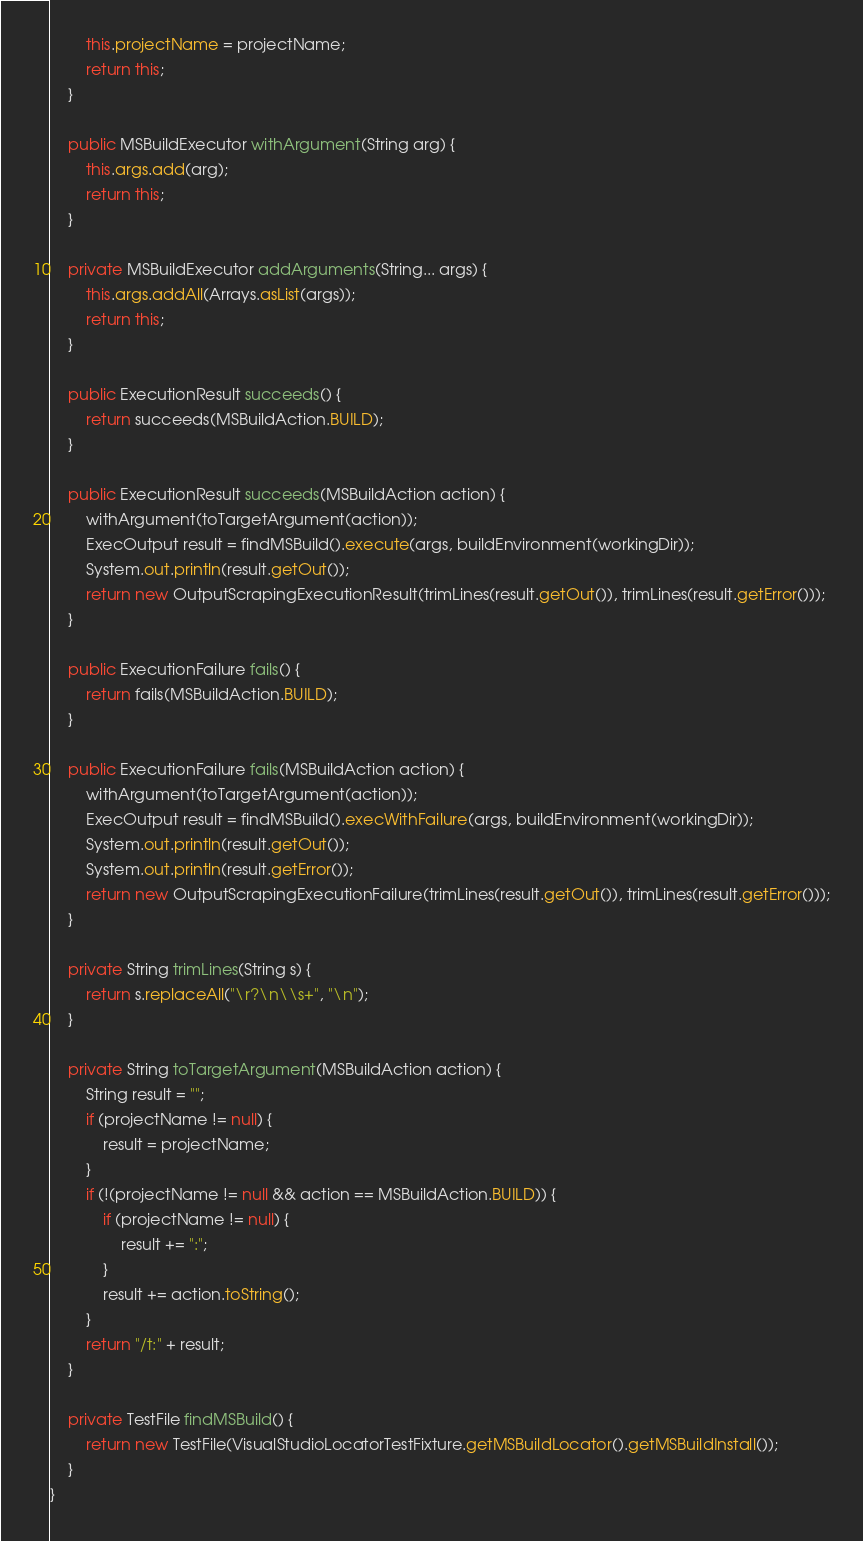<code> <loc_0><loc_0><loc_500><loc_500><_Java_>        this.projectName = projectName;
        return this;
    }

    public MSBuildExecutor withArgument(String arg) {
        this.args.add(arg);
        return this;
    }

    private MSBuildExecutor addArguments(String... args) {
        this.args.addAll(Arrays.asList(args));
        return this;
    }

    public ExecutionResult succeeds() {
        return succeeds(MSBuildAction.BUILD);
    }

    public ExecutionResult succeeds(MSBuildAction action) {
        withArgument(toTargetArgument(action));
        ExecOutput result = findMSBuild().execute(args, buildEnvironment(workingDir));
        System.out.println(result.getOut());
        return new OutputScrapingExecutionResult(trimLines(result.getOut()), trimLines(result.getError()));
    }

    public ExecutionFailure fails() {
        return fails(MSBuildAction.BUILD);
    }

    public ExecutionFailure fails(MSBuildAction action) {
        withArgument(toTargetArgument(action));
        ExecOutput result = findMSBuild().execWithFailure(args, buildEnvironment(workingDir));
        System.out.println(result.getOut());
        System.out.println(result.getError());
        return new OutputScrapingExecutionFailure(trimLines(result.getOut()), trimLines(result.getError()));
    }

    private String trimLines(String s) {
        return s.replaceAll("\r?\n\\s+", "\n");
    }

    private String toTargetArgument(MSBuildAction action) {
        String result = "";
        if (projectName != null) {
            result = projectName;
        }
        if (!(projectName != null && action == MSBuildAction.BUILD)) {
            if (projectName != null) {
                result += ":";
            }
            result += action.toString();
        }
        return "/t:" + result;
    }

    private TestFile findMSBuild() {
        return new TestFile(VisualStudioLocatorTestFixture.getMSBuildLocator().getMSBuildInstall());
    }
}
</code> 